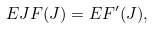<formula> <loc_0><loc_0><loc_500><loc_500>E J F ( J ) = E F ^ { \prime } ( J ) ,</formula> 